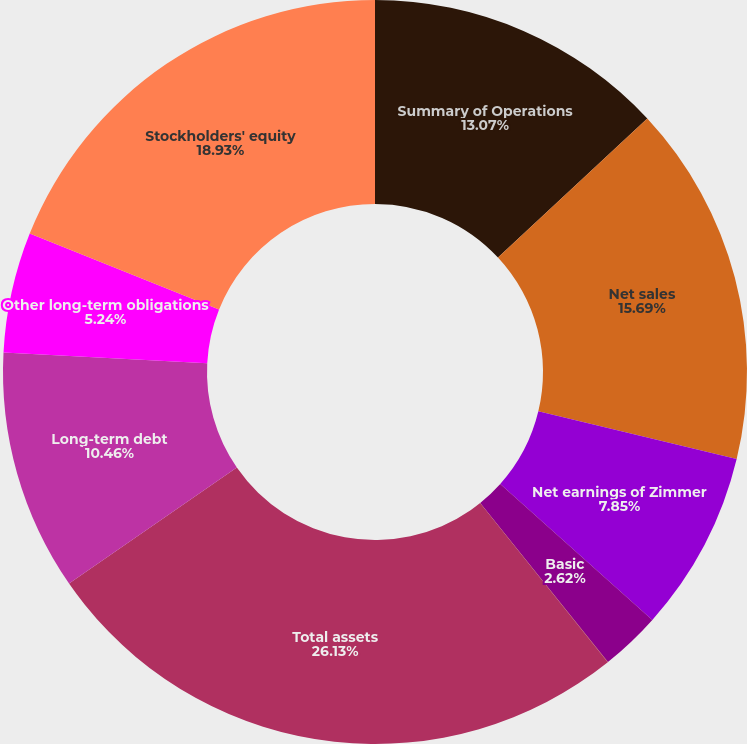<chart> <loc_0><loc_0><loc_500><loc_500><pie_chart><fcel>Summary of Operations<fcel>Net sales<fcel>Net earnings of Zimmer<fcel>Basic<fcel>Diluted<fcel>Total assets<fcel>Long-term debt<fcel>Other long-term obligations<fcel>Stockholders' equity<nl><fcel>13.07%<fcel>15.69%<fcel>7.85%<fcel>2.62%<fcel>0.01%<fcel>26.13%<fcel>10.46%<fcel>5.24%<fcel>18.93%<nl></chart> 